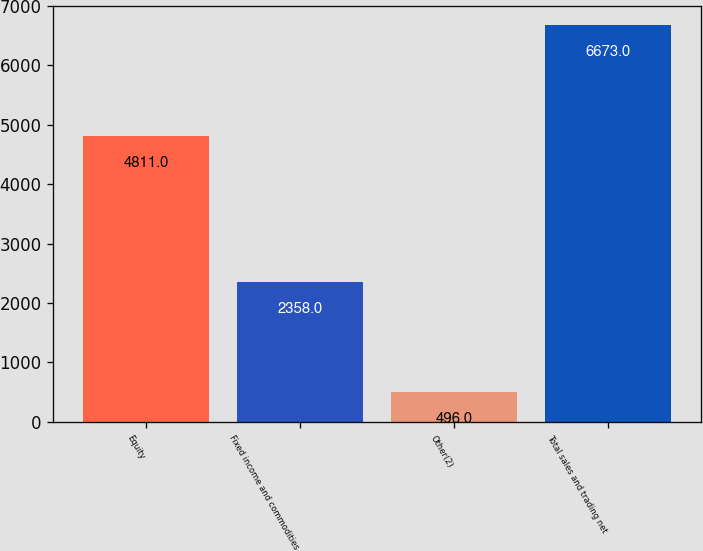Convert chart to OTSL. <chart><loc_0><loc_0><loc_500><loc_500><bar_chart><fcel>Equity<fcel>Fixed income and commodities<fcel>Other(2)<fcel>Total sales and trading net<nl><fcel>4811<fcel>2358<fcel>496<fcel>6673<nl></chart> 